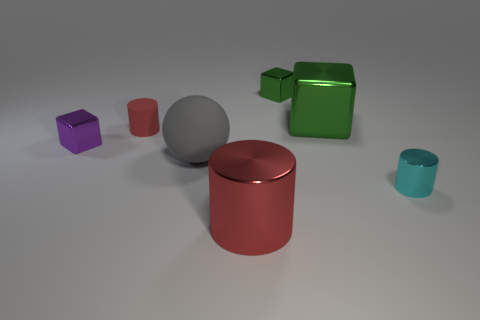There is a small purple object that is the same shape as the big green thing; what material is it?
Your answer should be compact. Metal. How many other matte objects have the same size as the gray rubber thing?
Keep it short and to the point. 0. What number of big red matte cubes are there?
Your answer should be very brief. 0. Is the large green object made of the same material as the tiny cylinder right of the big red thing?
Give a very brief answer. Yes. How many purple things are metal objects or matte things?
Provide a short and direct response. 1. There is a cyan thing that is the same material as the tiny green object; what size is it?
Provide a succinct answer. Small. What number of large red metal objects are the same shape as the small matte object?
Ensure brevity in your answer.  1. Is the number of tiny red cylinders that are right of the large block greater than the number of large rubber spheres that are behind the small green object?
Give a very brief answer. No. Is the color of the big rubber object the same as the metallic thing that is in front of the small cyan thing?
Your response must be concise. No. There is a green cube that is the same size as the gray matte ball; what is its material?
Keep it short and to the point. Metal. 